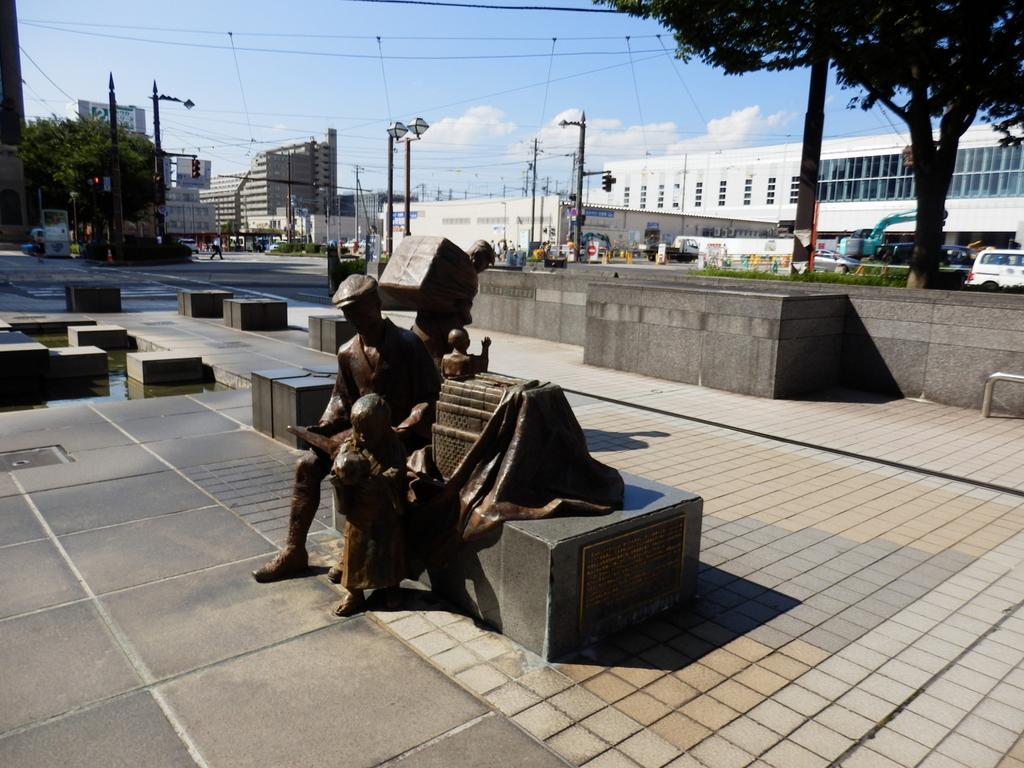Could you give a brief overview of what you see in this image? In this image we can see statues, few black color objects, few trees, buildings, light poles, traffic lights, vehicles and the sky with clouds. 